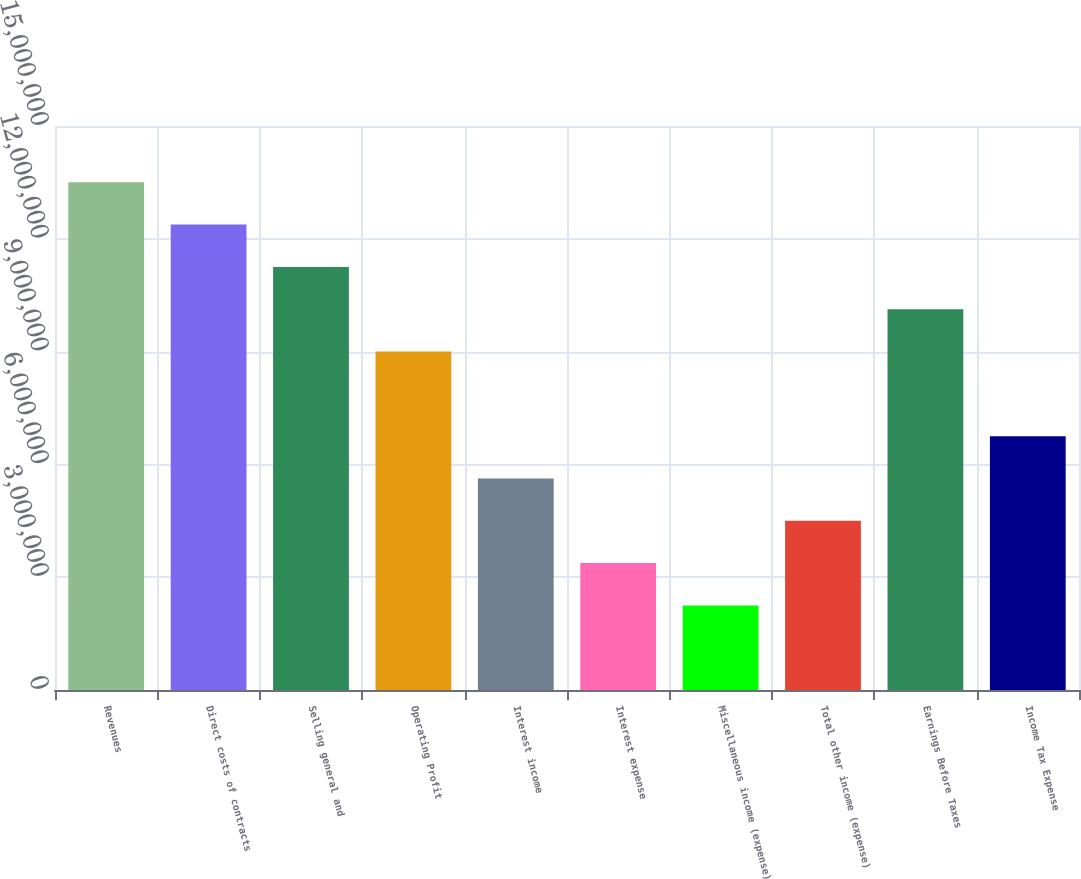<chart> <loc_0><loc_0><loc_500><loc_500><bar_chart><fcel>Revenues<fcel>Direct costs of contracts<fcel>Selling general and<fcel>Operating Profit<fcel>Interest income<fcel>Interest expense<fcel>Miscellaneous income (expense)<fcel>Total other income (expense)<fcel>Earnings Before Taxes<fcel>Income Tax Expense<nl><fcel>1.35026e+07<fcel>1.23774e+07<fcel>1.12522e+07<fcel>9.00173e+06<fcel>5.62608e+06<fcel>3.37565e+06<fcel>2.25043e+06<fcel>4.50087e+06<fcel>1.01269e+07<fcel>6.7513e+06<nl></chart> 